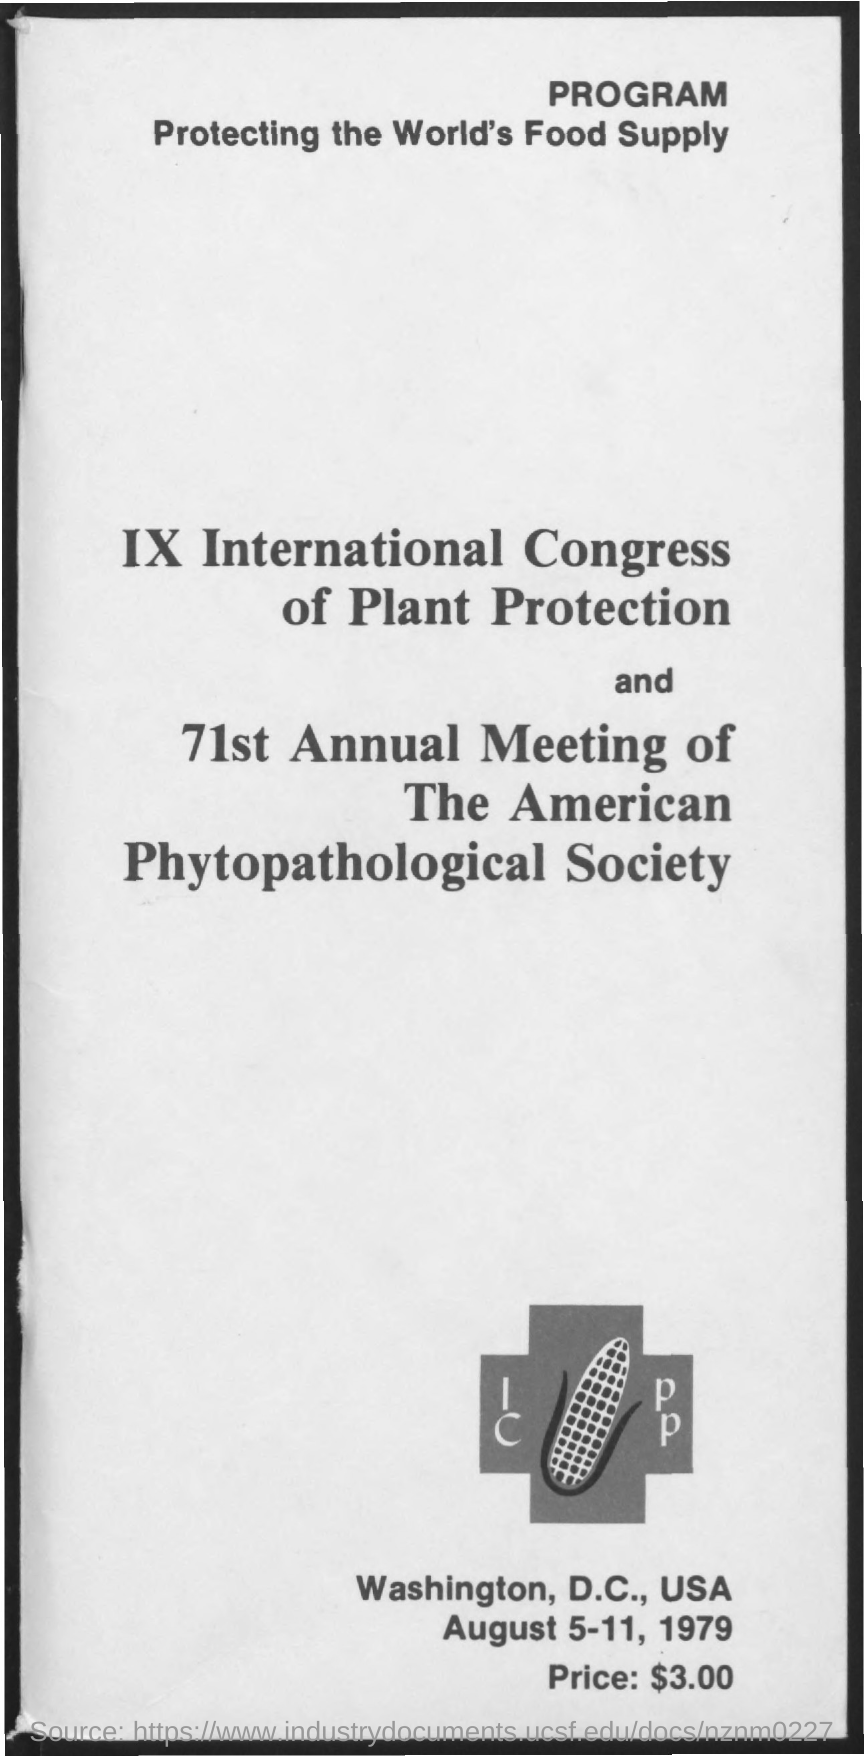What is the date mentioned in the given page ?
Provide a succinct answer. August 5-11, 1979. What is the price mentioned in the given page ?
Provide a succinct answer. $3.00. What is the name of the program mentioned ?
Offer a very short reply. Protecting the World's Food Supply. 